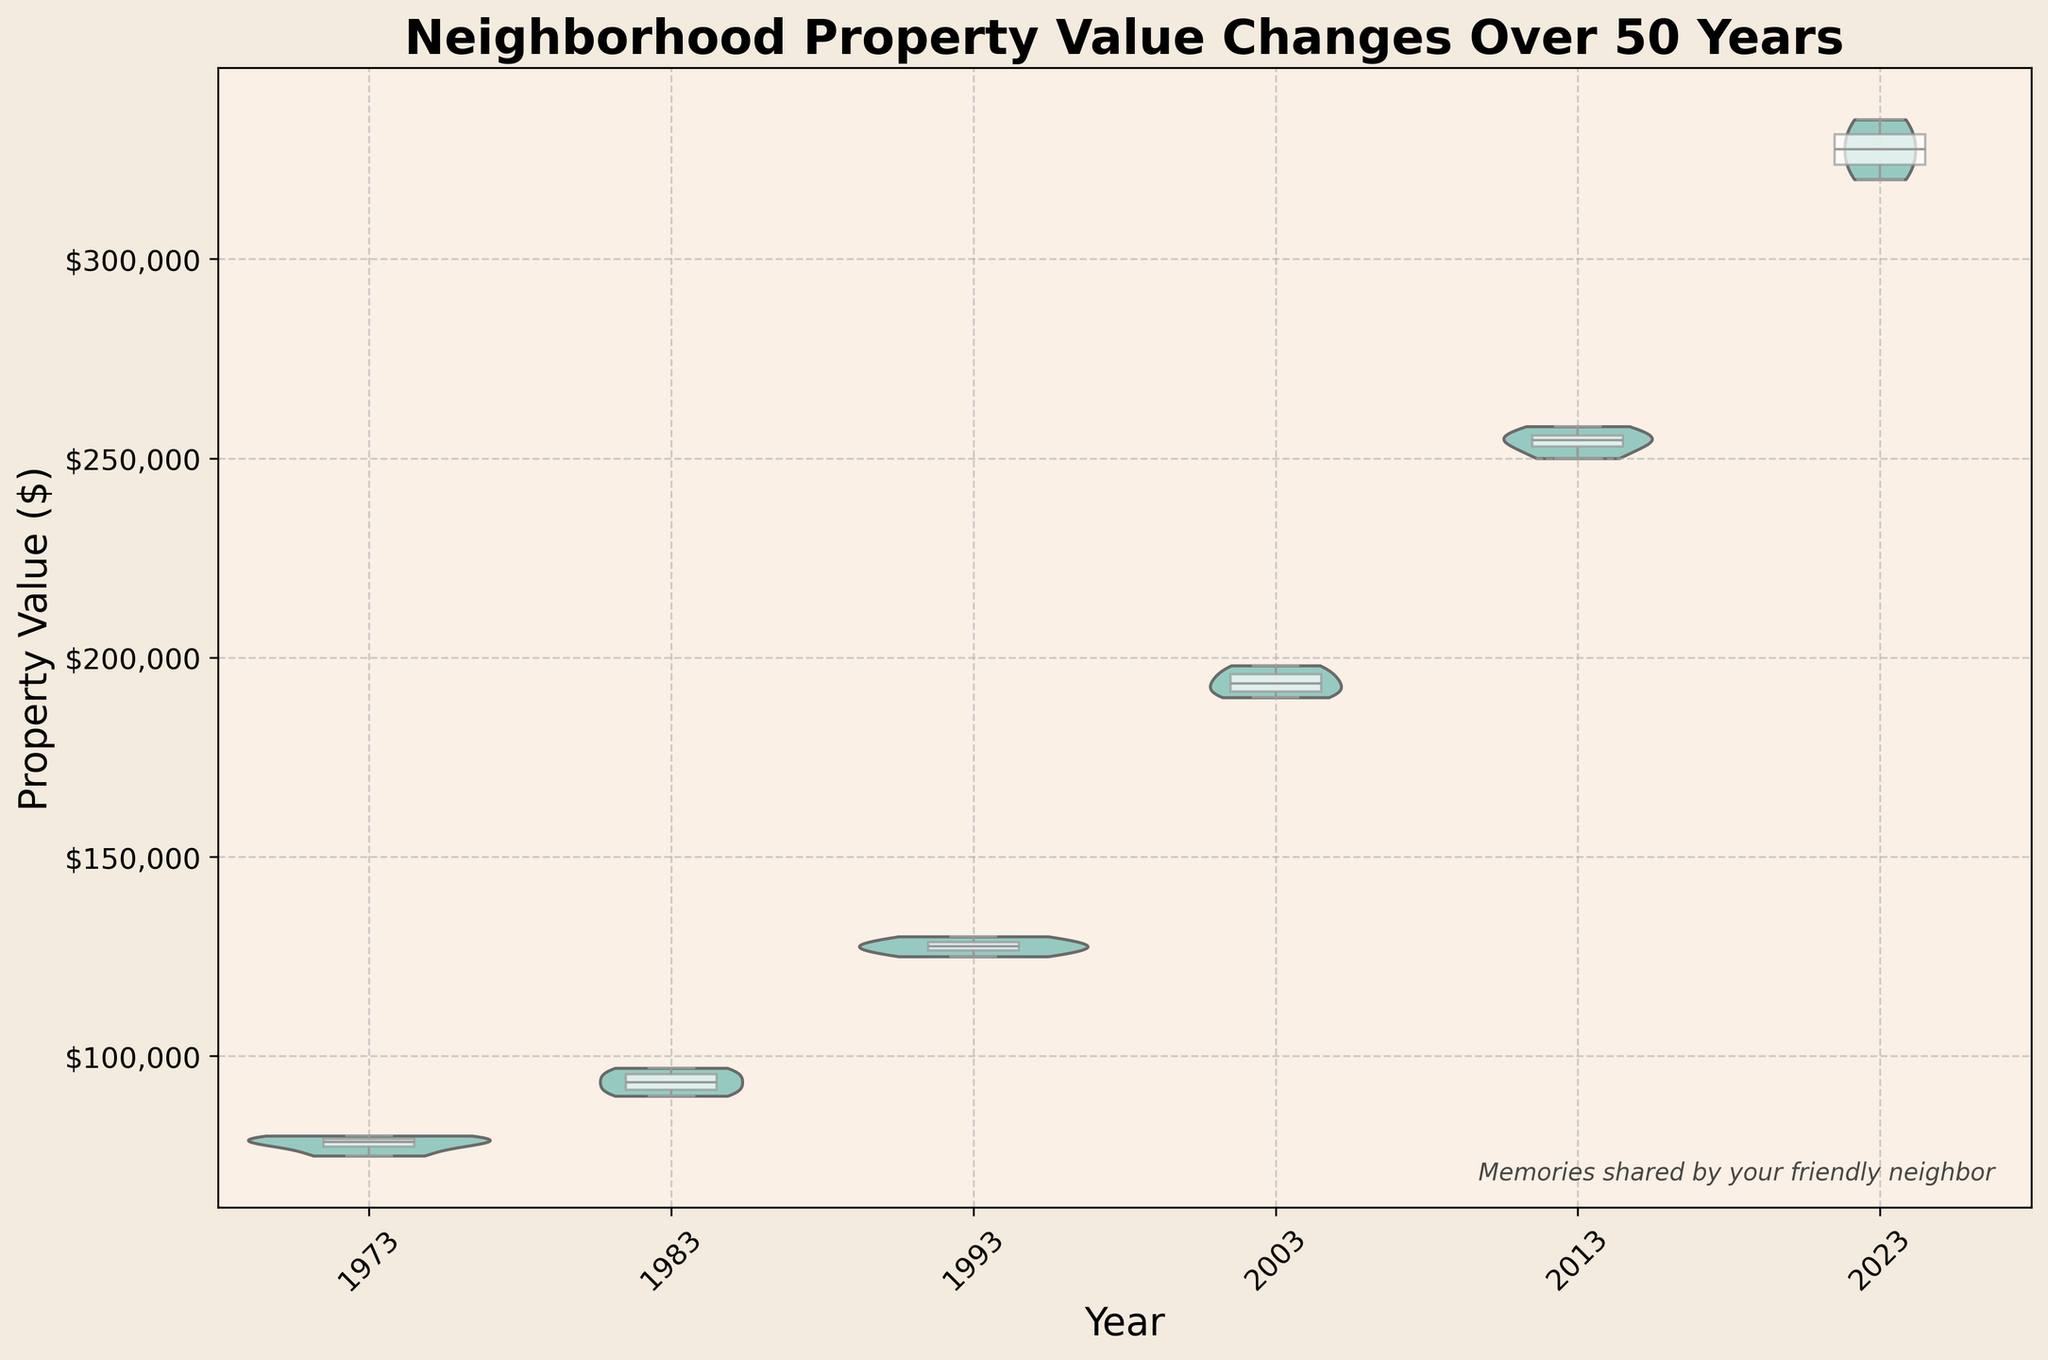What is the title of the figure? The title is generally found at the top of the figure, in a larger or bolder font. Here, it reads "Neighborhood Property Value Changes Over 50 Years".
Answer: Neighborhood Property Value Changes Over 50 Years What years are displayed on the x-axis? The x-axis typically displays categorical data here represented as years. The years shown are 1973, 1983, 1993, 2003, 2013, and 2023.
Answer: 1973, 1983, 1993, 2003, 2013, 2023 What is the property value range shown on the y-axis? The y-axis displays the range of property values, formatted as currency. The range starts from $70,000 and goes up to $350,000.
Answer: $70,000 to $350,000 How has the median property value changed from 1973 to 2023? To determine the median change, find the median points on the box plots for both 1973 and 2023. The median value for 1973 appears around $78,000 and for 2023 around $327,000. Subtract the former from the latter to find the change: $327,000 - $78,000 = $249,000.
Answer: Increased by $249,000 Which year shows the highest property value spread? To find the highest spread, look for the year with the widest violin shape or largest range in the box plot. 2023 has the broadest range from around $320,000 to $335,000.
Answer: 2023 Did property values rise continually over the 50 years shown? Examine the median points in the box plots from each year. Despite some variations, the general trend shows an increase in median values over the years.
Answer: Yes What is the interquartile range (IQR) for property values in 2003? The IQR is the range between the first quartile (Q1) and third quartile (Q3) in the box plot. For 2003, Q1 is around $192,000, and Q3 is around $198,000. Thus, IQR = $198,000 - $192,000 = $6,000.
Answer: $6,000 Which year shows the least variability in property values? The year with the narrowest violin plot indicates the least variability. 1983 seems to show the least spread in values.
Answer: 1983 What nostalgic annotation is present on the figure? Locate any textual annotations included for aesthetic or informational purposes. The figure has a nostalgic text in the lower right corner: "Memories shared by your friendly neighbor".
Answer: Memories shared by your friendly neighbor What is the general trend in property values over the 50 years? Observe the overall direction of the median points in the box plots from each year. The property values show a general upward trend across the five decades.
Answer: Increasing 